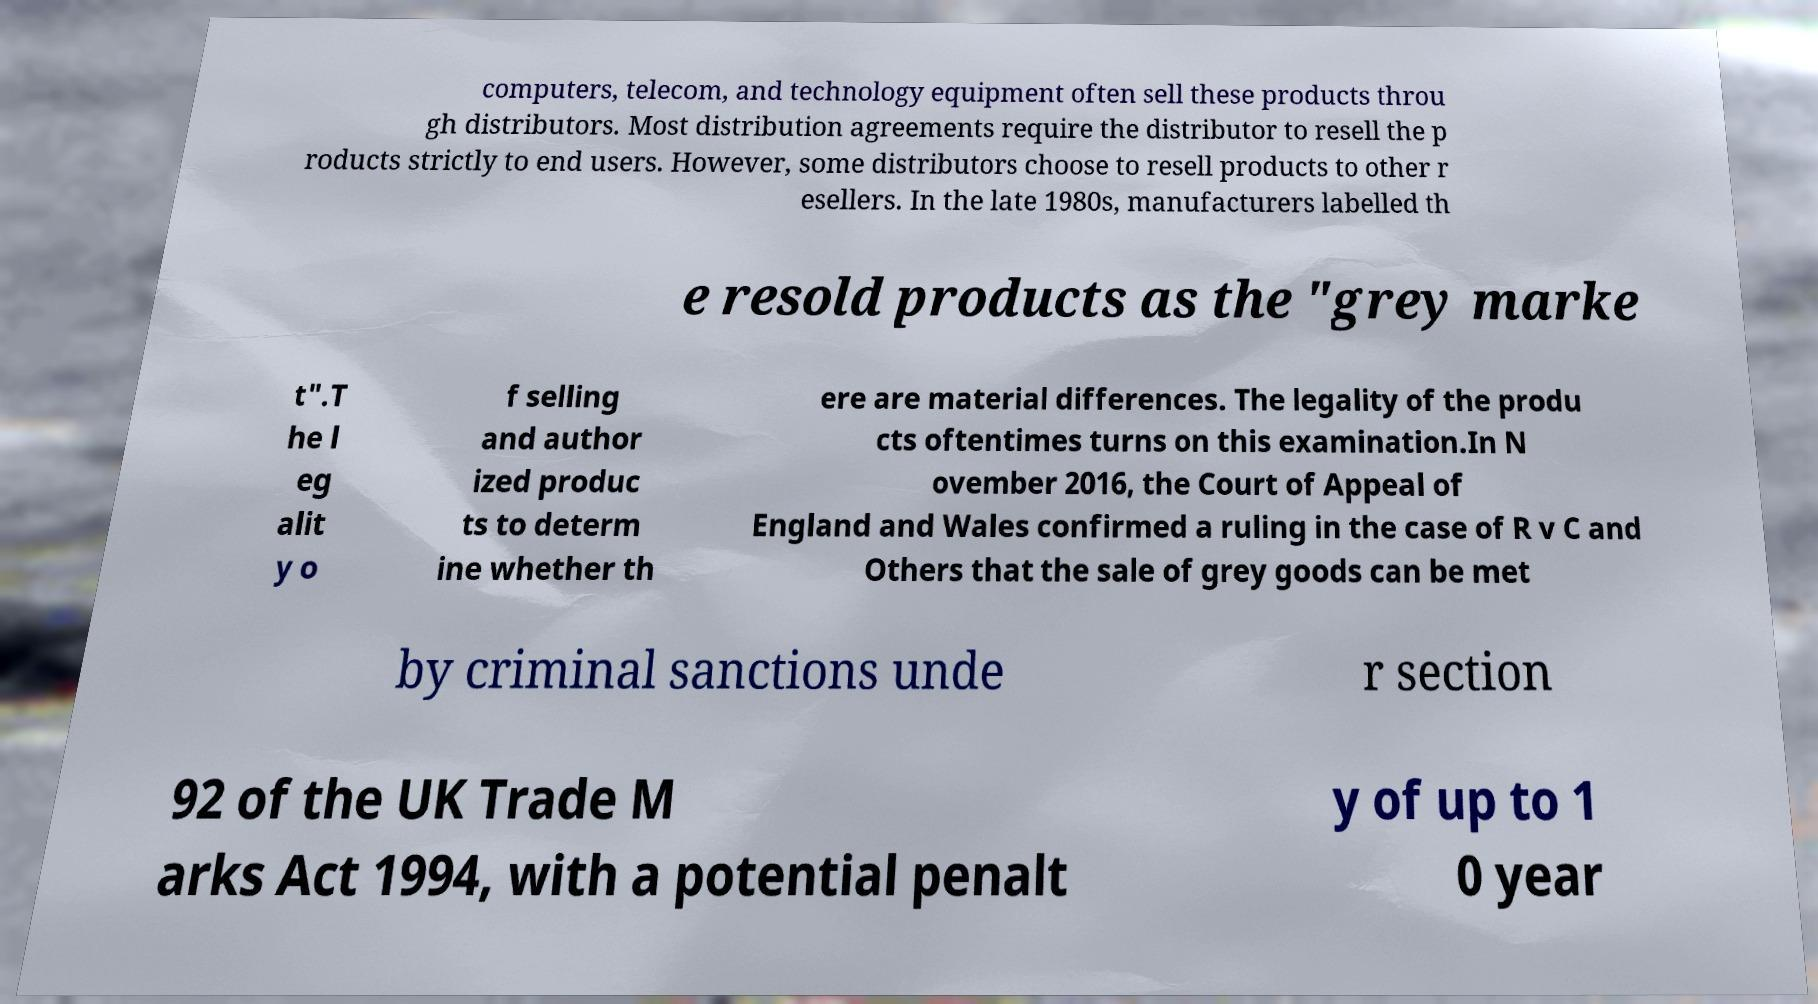Please read and relay the text visible in this image. What does it say? computers, telecom, and technology equipment often sell these products throu gh distributors. Most distribution agreements require the distributor to resell the p roducts strictly to end users. However, some distributors choose to resell products to other r esellers. In the late 1980s, manufacturers labelled th e resold products as the "grey marke t".T he l eg alit y o f selling and author ized produc ts to determ ine whether th ere are material differences. The legality of the produ cts oftentimes turns on this examination.In N ovember 2016, the Court of Appeal of England and Wales confirmed a ruling in the case of R v C and Others that the sale of grey goods can be met by criminal sanctions unde r section 92 of the UK Trade M arks Act 1994, with a potential penalt y of up to 1 0 year 